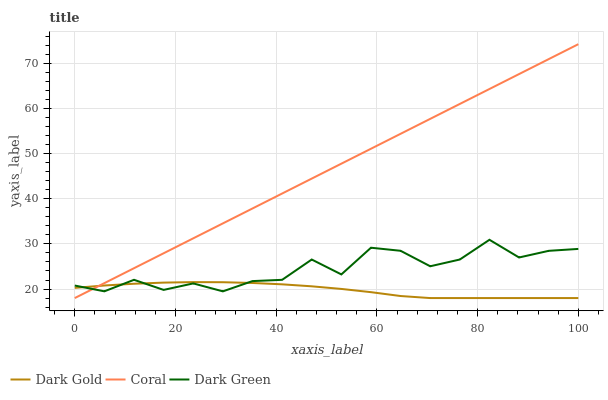Does Dark Gold have the minimum area under the curve?
Answer yes or no. Yes. Does Coral have the maximum area under the curve?
Answer yes or no. Yes. Does Dark Green have the minimum area under the curve?
Answer yes or no. No. Does Dark Green have the maximum area under the curve?
Answer yes or no. No. Is Coral the smoothest?
Answer yes or no. Yes. Is Dark Green the roughest?
Answer yes or no. Yes. Is Dark Gold the smoothest?
Answer yes or no. No. Is Dark Gold the roughest?
Answer yes or no. No. Does Coral have the lowest value?
Answer yes or no. Yes. Does Dark Green have the lowest value?
Answer yes or no. No. Does Coral have the highest value?
Answer yes or no. Yes. Does Dark Green have the highest value?
Answer yes or no. No. Does Dark Gold intersect Dark Green?
Answer yes or no. Yes. Is Dark Gold less than Dark Green?
Answer yes or no. No. Is Dark Gold greater than Dark Green?
Answer yes or no. No. 